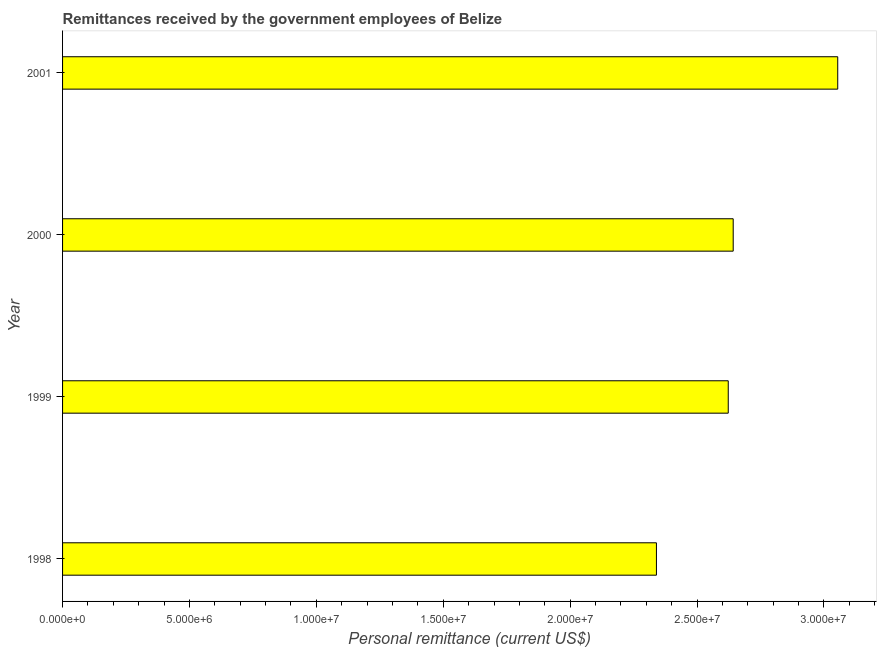Does the graph contain any zero values?
Offer a very short reply. No. What is the title of the graph?
Offer a very short reply. Remittances received by the government employees of Belize. What is the label or title of the X-axis?
Offer a very short reply. Personal remittance (current US$). What is the personal remittances in 2001?
Provide a short and direct response. 3.05e+07. Across all years, what is the maximum personal remittances?
Your answer should be compact. 3.05e+07. Across all years, what is the minimum personal remittances?
Provide a succinct answer. 2.34e+07. In which year was the personal remittances minimum?
Ensure brevity in your answer.  1998. What is the sum of the personal remittances?
Keep it short and to the point. 1.07e+08. What is the difference between the personal remittances in 1999 and 2000?
Keep it short and to the point. -1.95e+05. What is the average personal remittances per year?
Your answer should be very brief. 2.66e+07. What is the median personal remittances?
Offer a terse response. 2.63e+07. In how many years, is the personal remittances greater than 30000000 US$?
Give a very brief answer. 1. What is the ratio of the personal remittances in 1998 to that in 1999?
Your answer should be compact. 0.89. Is the difference between the personal remittances in 1999 and 2001 greater than the difference between any two years?
Your answer should be very brief. No. What is the difference between the highest and the second highest personal remittances?
Offer a very short reply. 4.12e+06. What is the difference between the highest and the lowest personal remittances?
Your response must be concise. 7.14e+06. Are all the bars in the graph horizontal?
Give a very brief answer. Yes. How many years are there in the graph?
Your answer should be very brief. 4. What is the difference between two consecutive major ticks on the X-axis?
Provide a succinct answer. 5.00e+06. Are the values on the major ticks of X-axis written in scientific E-notation?
Keep it short and to the point. Yes. What is the Personal remittance (current US$) in 1998?
Ensure brevity in your answer.  2.34e+07. What is the Personal remittance (current US$) of 1999?
Provide a short and direct response. 2.62e+07. What is the Personal remittance (current US$) of 2000?
Your answer should be very brief. 2.64e+07. What is the Personal remittance (current US$) of 2001?
Make the answer very short. 3.05e+07. What is the difference between the Personal remittance (current US$) in 1998 and 1999?
Your answer should be compact. -2.83e+06. What is the difference between the Personal remittance (current US$) in 1998 and 2000?
Provide a succinct answer. -3.02e+06. What is the difference between the Personal remittance (current US$) in 1998 and 2001?
Your answer should be very brief. -7.14e+06. What is the difference between the Personal remittance (current US$) in 1999 and 2000?
Your response must be concise. -1.95e+05. What is the difference between the Personal remittance (current US$) in 1999 and 2001?
Offer a terse response. -4.31e+06. What is the difference between the Personal remittance (current US$) in 2000 and 2001?
Offer a very short reply. -4.12e+06. What is the ratio of the Personal remittance (current US$) in 1998 to that in 1999?
Offer a very short reply. 0.89. What is the ratio of the Personal remittance (current US$) in 1998 to that in 2000?
Offer a terse response. 0.89. What is the ratio of the Personal remittance (current US$) in 1998 to that in 2001?
Provide a short and direct response. 0.77. What is the ratio of the Personal remittance (current US$) in 1999 to that in 2000?
Your answer should be compact. 0.99. What is the ratio of the Personal remittance (current US$) in 1999 to that in 2001?
Your answer should be very brief. 0.86. What is the ratio of the Personal remittance (current US$) in 2000 to that in 2001?
Offer a terse response. 0.86. 